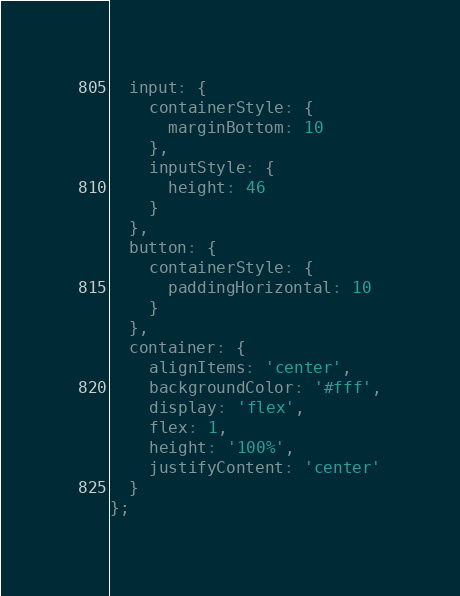<code> <loc_0><loc_0><loc_500><loc_500><_JavaScript_>  input: {
    containerStyle: {
      marginBottom: 10
    },
    inputStyle: {
      height: 46
    }
  },
  button: {
    containerStyle: {
      paddingHorizontal: 10
    }
  },
  container: {
    alignItems: 'center',
    backgroundColor: '#fff',
    display: 'flex',
    flex: 1,
    height: '100%',
    justifyContent: 'center'
  }
};
</code> 